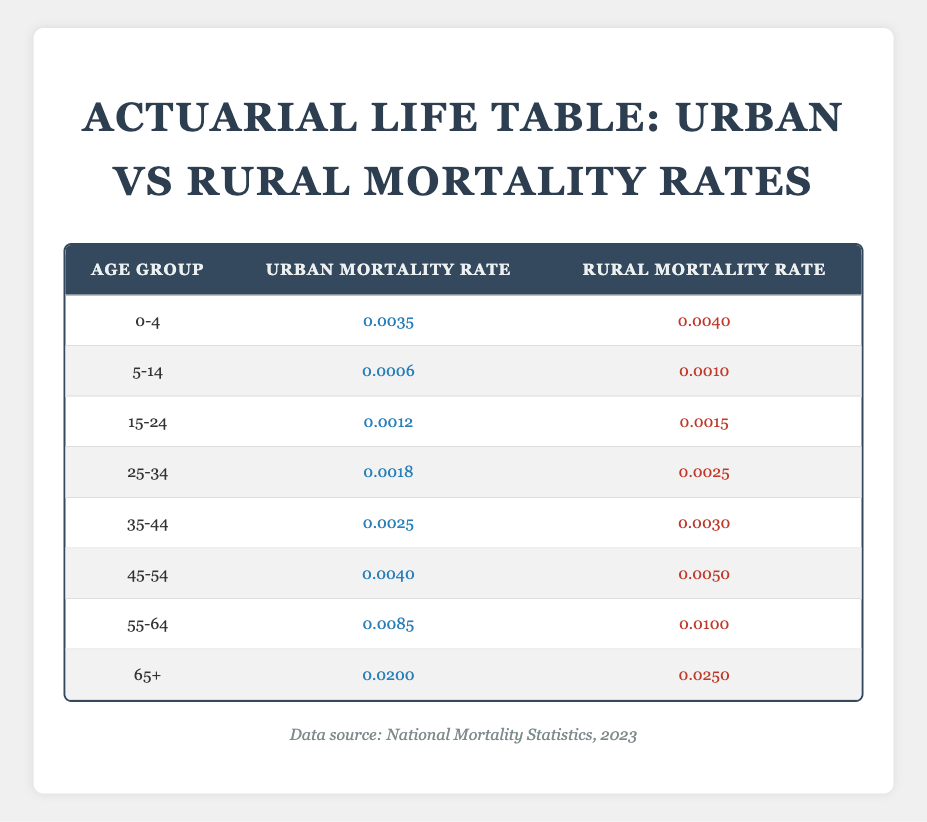What is the urban mortality rate for ages 0-4? The table shows an urban mortality rate of 0.0035 for the age range of 0-4.
Answer: 0.0035 What is the difference in mortality rates between urban and rural populations for ages 55-64? For the age group 55-64, the urban mortality rate is 0.0085 and the rural mortality rate is 0.0100. The difference is calculated as 0.0100 - 0.0085 = 0.0015.
Answer: 0.0015 Is the rural mortality rate higher than the urban rate for ages 25-34? The table indicates that the urban mortality rate for ages 25-34 is 0.0018 while the rural rate is 0.0025, confirming that the rural rate is higher.
Answer: Yes Which age group has the highest urban mortality rate? Reviewing the table, the age group 65+ has the highest urban mortality rate at 0.0200.
Answer: 65+ What is the average urban mortality rate across all age groups? To find the average urban mortality rate, sum up the rates for all age groups: 0.0035 + 0.0006 + 0.0012 + 0.0018 + 0.0025 + 0.0040 + 0.0085 + 0.0200 = 0.0421. Then divide by the number of groups (8): 0.0421 / 8 = 0.0052625, which can be rounded to 0.0053.
Answer: 0.0053 Is the mortality rate for ages 15-24 in the rural population less than the rate for ages 45-54 in the urban population? The rural mortality rate for ages 15-24 is 0.0015, and the urban mortality rate for ages 45-54 is 0.0040. Since 0.0015 is less than 0.0040, the statement is true.
Answer: Yes What age group shows the smallest difference in mortality rates between urban and rural populations? Examining the table, the age group 5-14 has an urban mortality rate of 0.0006 and a rural rate of 0.0010. The difference is 0.0010 - 0.0006 = 0.0004, which is smaller than other age differences shown.
Answer: 5-14 What percentage increase in mortality rate is observed for ages 65+ when comparing rural to urban populations? For ages 65+, the urban rate is 0.0200 and the rural rate is 0.0250. The increase can be calculated: (0.0250 - 0.0200) / 0.0200 × 100 = 25%.
Answer: 25% What is the total rural mortality rate for ages 0-4 and 5-14 combined? The rural mortality rates for ages 0-4 and 5-14 are 0.0040 and 0.0010, respectively. Adding these rates gives 0.0040 + 0.0010 = 0.0050.
Answer: 0.0050 